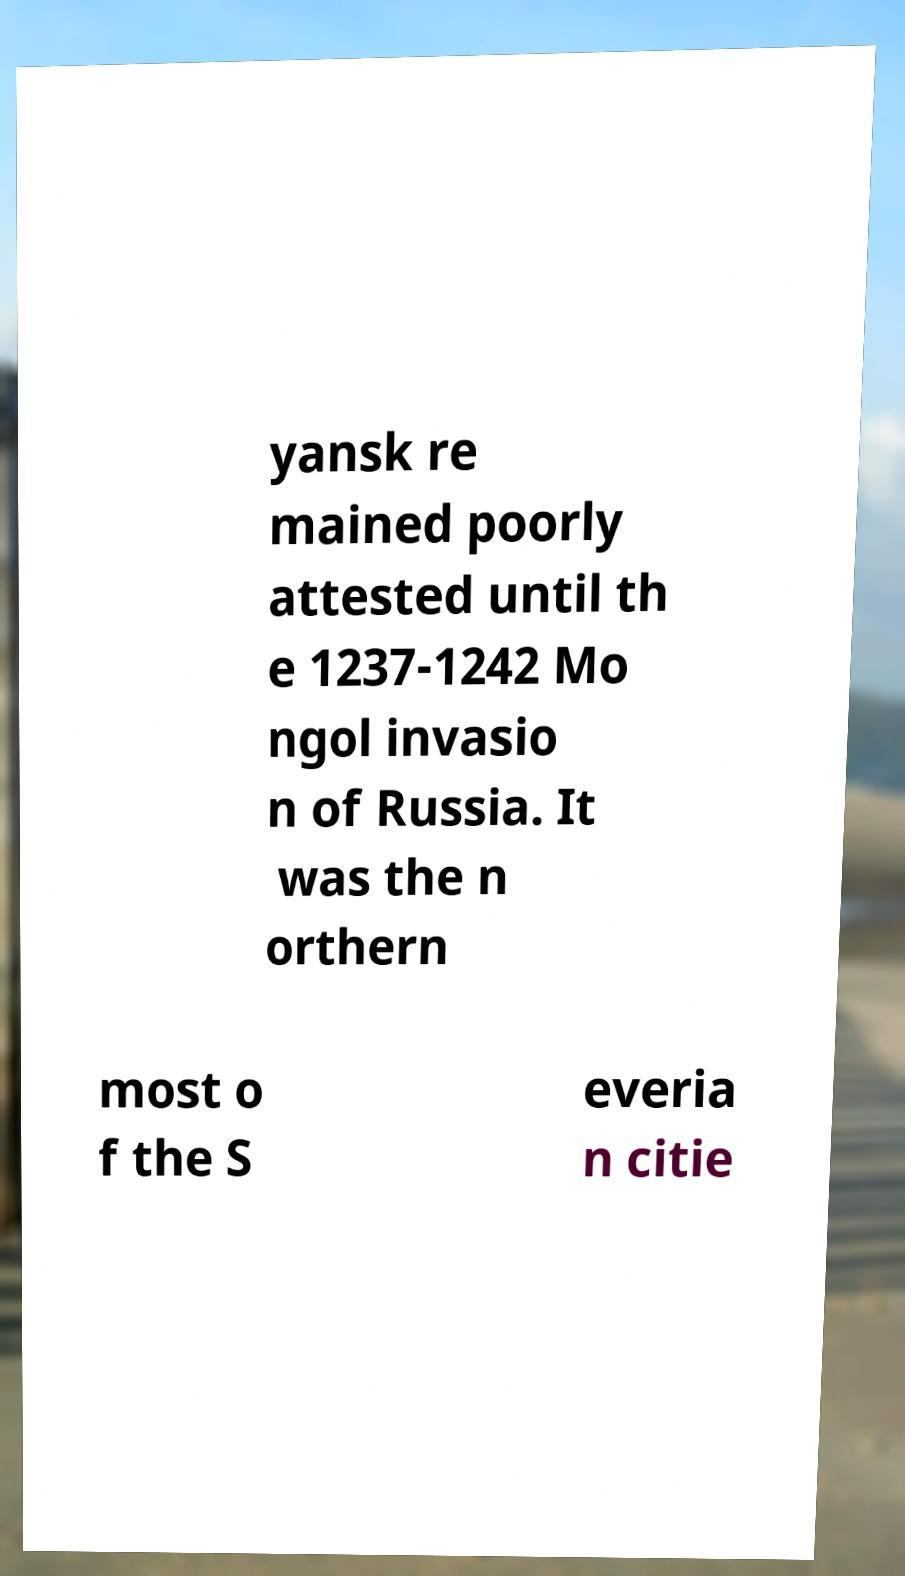I need the written content from this picture converted into text. Can you do that? yansk re mained poorly attested until th e 1237-1242 Mo ngol invasio n of Russia. It was the n orthern most o f the S everia n citie 